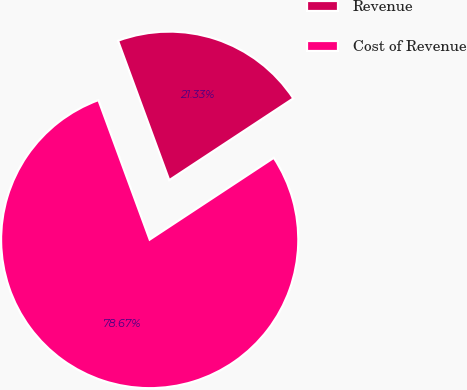Convert chart. <chart><loc_0><loc_0><loc_500><loc_500><pie_chart><fcel>Revenue<fcel>Cost of Revenue<nl><fcel>21.33%<fcel>78.67%<nl></chart> 